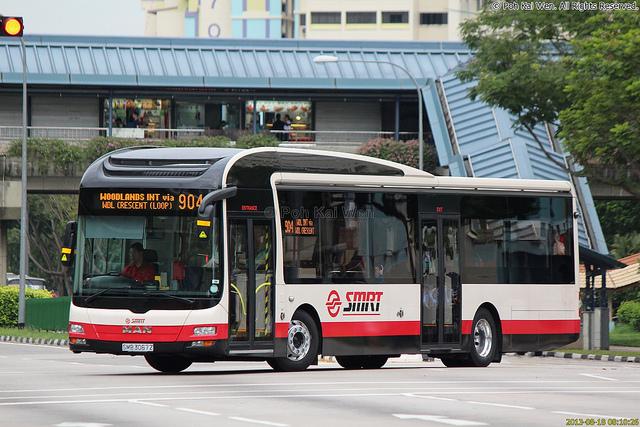How many tires are on the bus?
Answer briefly. 6. What is the bus number?
Short answer required. 904. Where is this bus going?
Keep it brief. Woodlands. What is the number of the bus?
Give a very brief answer. 904. 